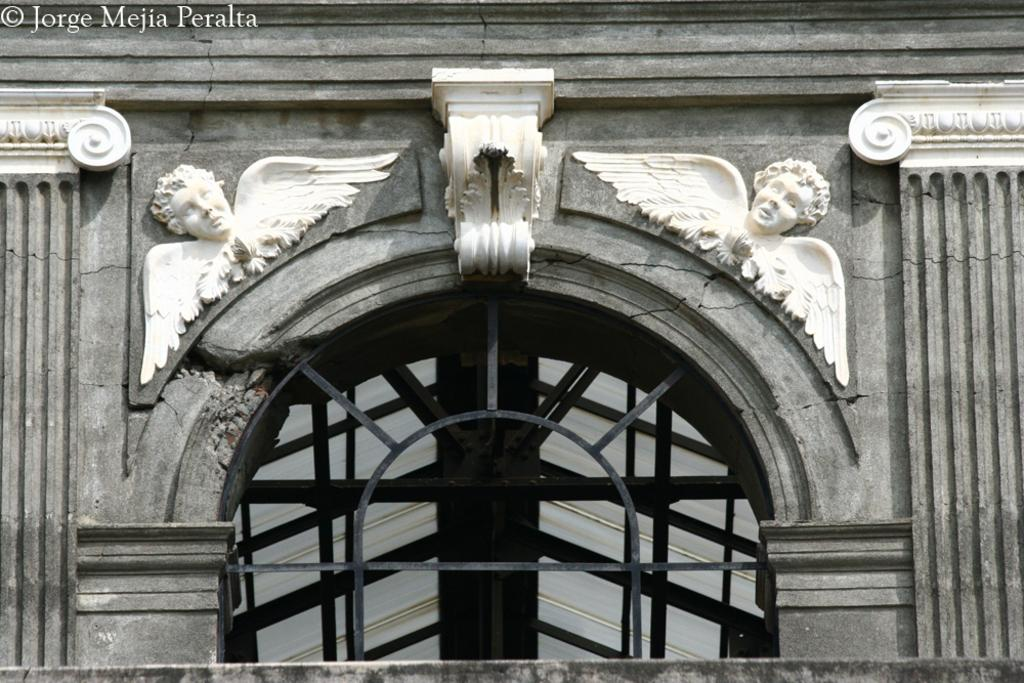What can be seen in the image that indicates it is a specific type of document or artwork? There is a watermark in the image. What type of art or decoration is present on a wall in the image? There are sculptures on a wall in the image. What architectural feature is present on a wall in the image? There is a window on a wall in the image. What color scheme is used in the image? The image is black and white in color. What type of toy can be seen playing with a sponge in the image? There is no toy or sponge present in the image; it features a watermark, sculptures, and a window in a black and white color scheme. 